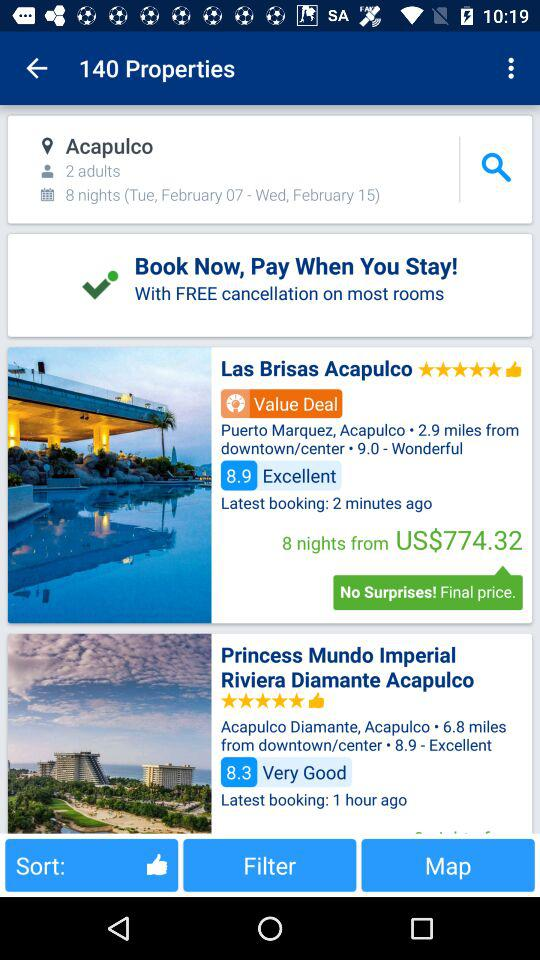What is the star rating of the Princess Mundo Imperial Riviera Diamante Acapulco? The rating is 5 stars. 